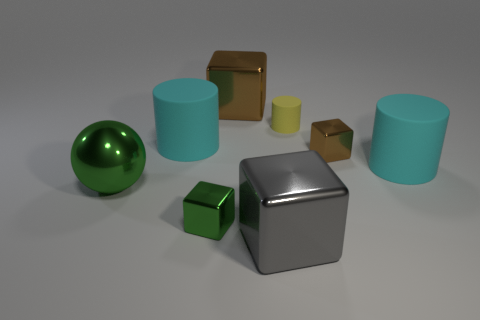Can you describe the lighting direction in this image? Certainly! The lighting in the image appears to be coming from the upper left-hand side. This is indicated by the shadows cast towards the bottom right of the objects, which suggests a directional light source above and to the left of this arrangement of objects. How does the lighting affect the appearance of the objects? The lighting dramatically affects the appearance and perception of these objects. It highlights the textures, reflecting off the shiny surfaces and enhancing the metallic luster. Shadows create depth and contrast, while also allowing us to infer the three-dimensional form of each object and understand the spatial relationship between them. 